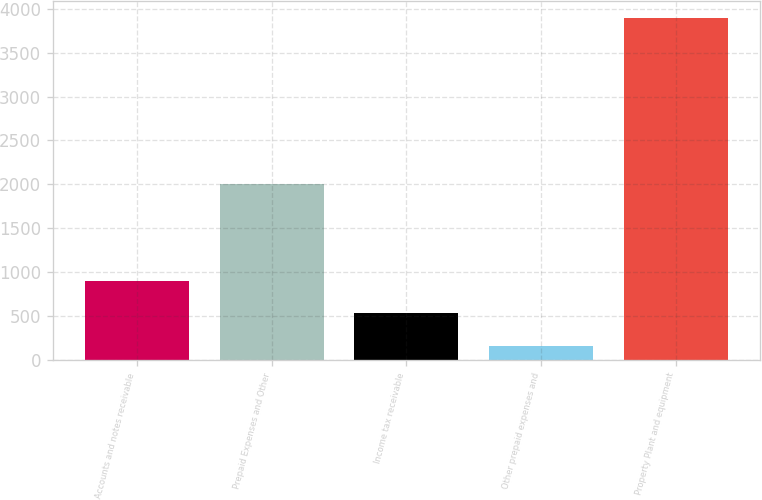<chart> <loc_0><loc_0><loc_500><loc_500><bar_chart><fcel>Accounts and notes receivable<fcel>Prepaid Expenses and Other<fcel>Income tax receivable<fcel>Other prepaid expenses and<fcel>Property Plant and equipment<nl><fcel>904.6<fcel>2009<fcel>530.3<fcel>156<fcel>3899<nl></chart> 